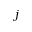<formula> <loc_0><loc_0><loc_500><loc_500>j</formula> 